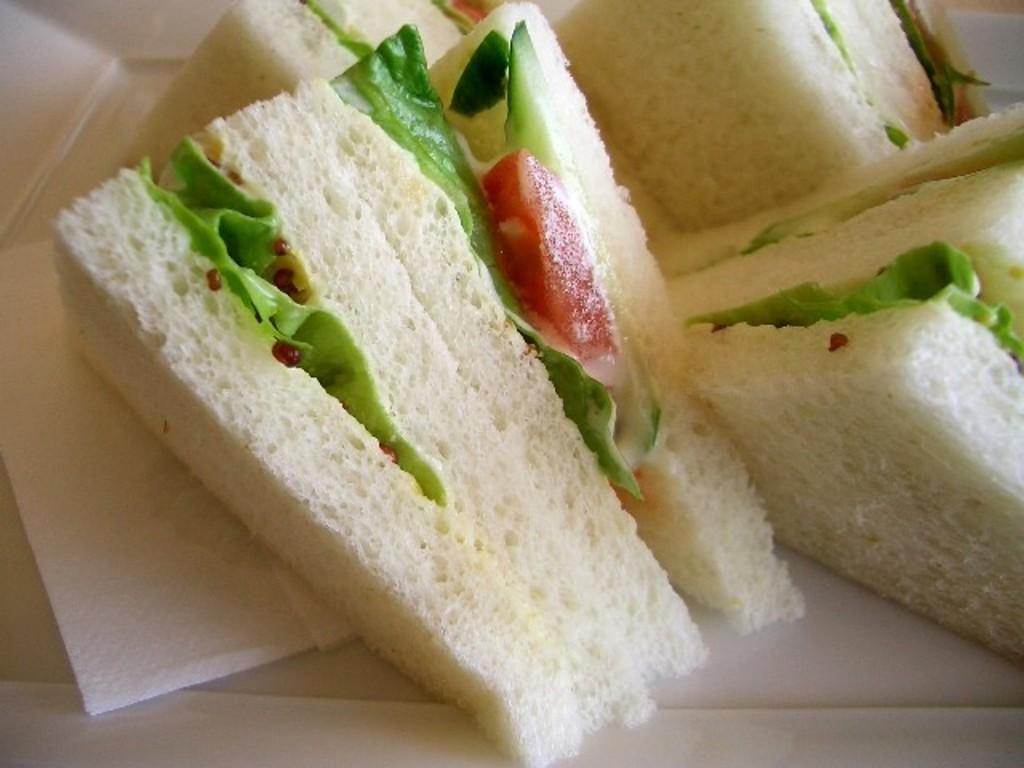What type of food is featured in the image? There are stuffed sandwiches in the image. What else can be seen in the image besides the sandwiches? Tissue papers are present in the image. How many children are waving good-bye in the image? There are no children or any good-bye gestures present in the image. What type of leaf can be seen falling from the tree in the image? There is no tree or leaf present in the image. 